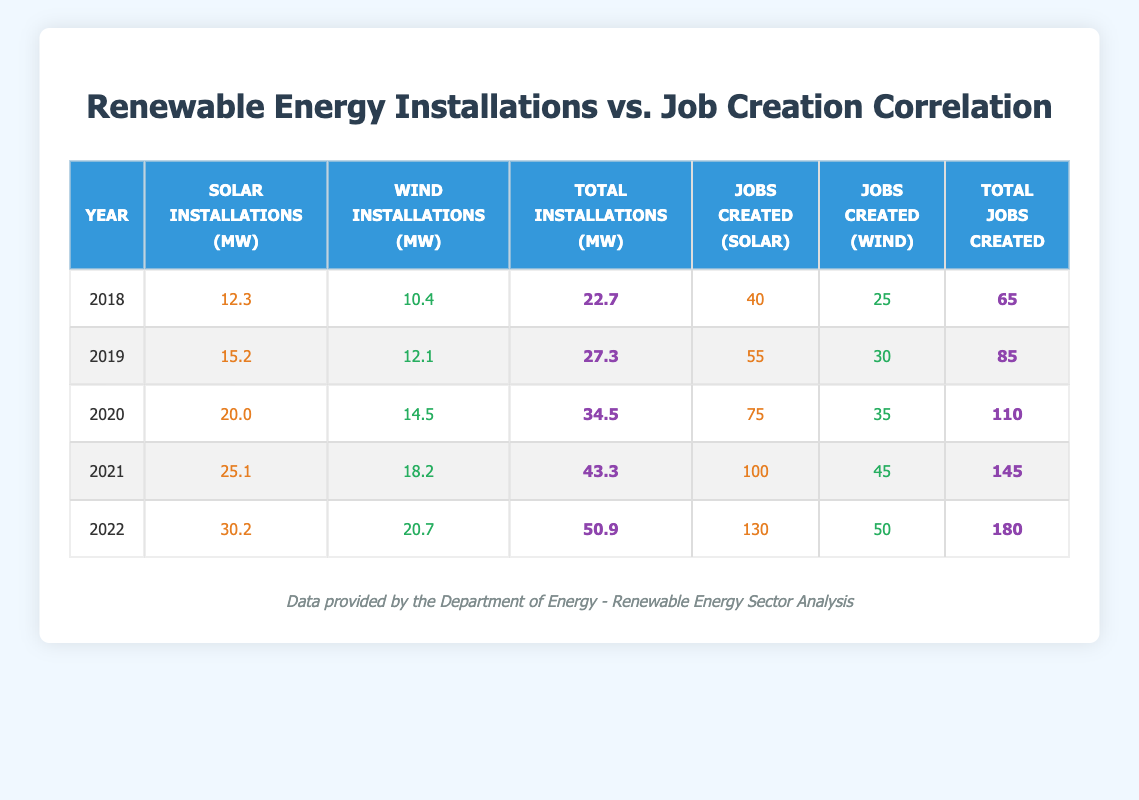What is the total number of jobs created in 2020? In 2020, the total jobs created is listed in the table as 110.
Answer: 110 What was the solar installation in megawatts in 2021? In the year 2021, the table shows that solar installations were 25.1 MW.
Answer: 25.1 MW What is the average number of jobs created from 2018 to 2022? To find the average, sum the total jobs created each year: (65 + 85 + 110 + 145 + 180) = 585. There are 5 years, so the average is 585 / 5 = 117.
Answer: 117 Did wind installations increase each year from 2018 to 2022? Looking at the wind installations for each year: 10.4, 12.1, 14.5, 18.2, 20.7, it shows a consistent increase without any decreases.
Answer: Yes What is the difference in total jobs created between 2018 and 2022? The total jobs created in 2018 is 65, and in 2022 it is 180. To find the difference, subtract: 180 - 65 = 115.
Answer: 115 In which year was the highest number of jobs created for solar installations? The table indicates that the highest number of jobs created for solar installations was in the year 2022, with 130 jobs.
Answer: 2022 What was the total number of megawatts installed in 2019? The table shows that the total installations in 2019 amounted to 27.3 MW.
Answer: 27.3 MW What year showed the least amount of total installations in megawatts? Comparing the total installations: 22.7 in 2018, 27.3 in 2019, 34.5 in 2020, 43.3 in 2021, and 50.9 in 2022, the least was in 2018.
Answer: 2018 How many jobs were created for wind installations in 2020? According to the table, in 2020, the number of jobs created for wind installations was 35.
Answer: 35 